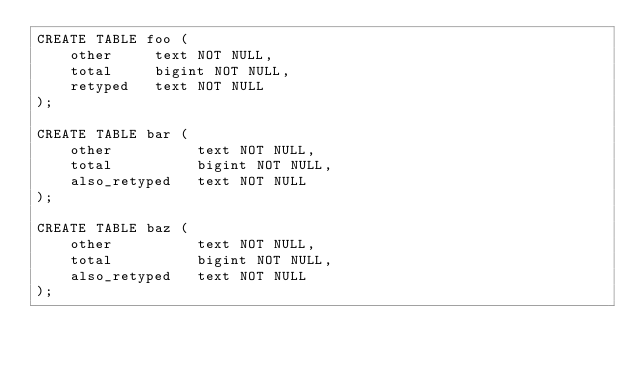<code> <loc_0><loc_0><loc_500><loc_500><_SQL_>CREATE TABLE foo (
    other     text NOT NULL,
    total     bigint NOT NULL,
    retyped   text NOT NULL
);

CREATE TABLE bar (
    other          text NOT NULL,
    total          bigint NOT NULL,
    also_retyped   text NOT NULL
);

CREATE TABLE baz (
    other          text NOT NULL,
    total          bigint NOT NULL,
    also_retyped   text NOT NULL
);
</code> 